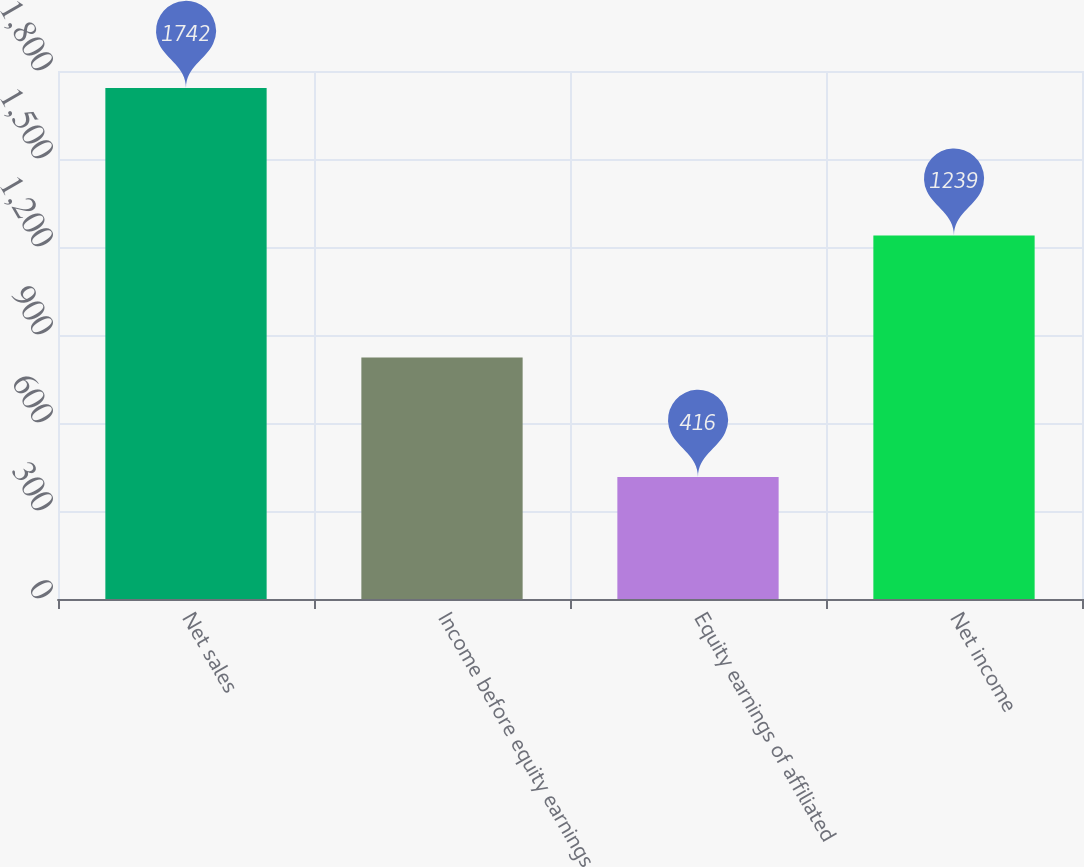<chart> <loc_0><loc_0><loc_500><loc_500><bar_chart><fcel>Net sales<fcel>Income before equity earnings<fcel>Equity earnings of affiliated<fcel>Net income<nl><fcel>1742<fcel>823<fcel>416<fcel>1239<nl></chart> 